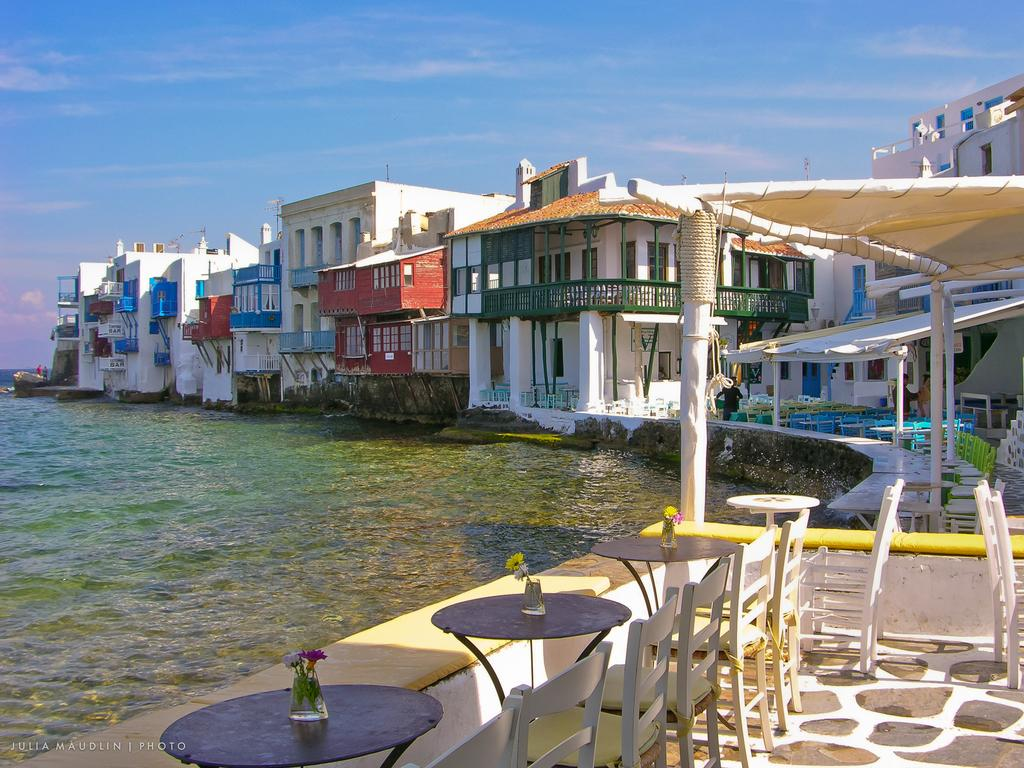What type of natural feature is present in the image? There is a river in the image. What type of furniture is located near the river? There are tables and chairs beside the river. What can be seen in the distance in the image? There are houses in the background of the image. What is visible above the river and houses in the image? The sky is visible in the image. What type of theory is being discussed at the tables and chairs beside the river? There is no indication in the image that a theory is being discussed at the tables and chairs beside the river. Can you see a pan in the image? There is no pan present in the image. 